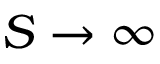<formula> <loc_0><loc_0><loc_500><loc_500>S \rightarrow \infty</formula> 